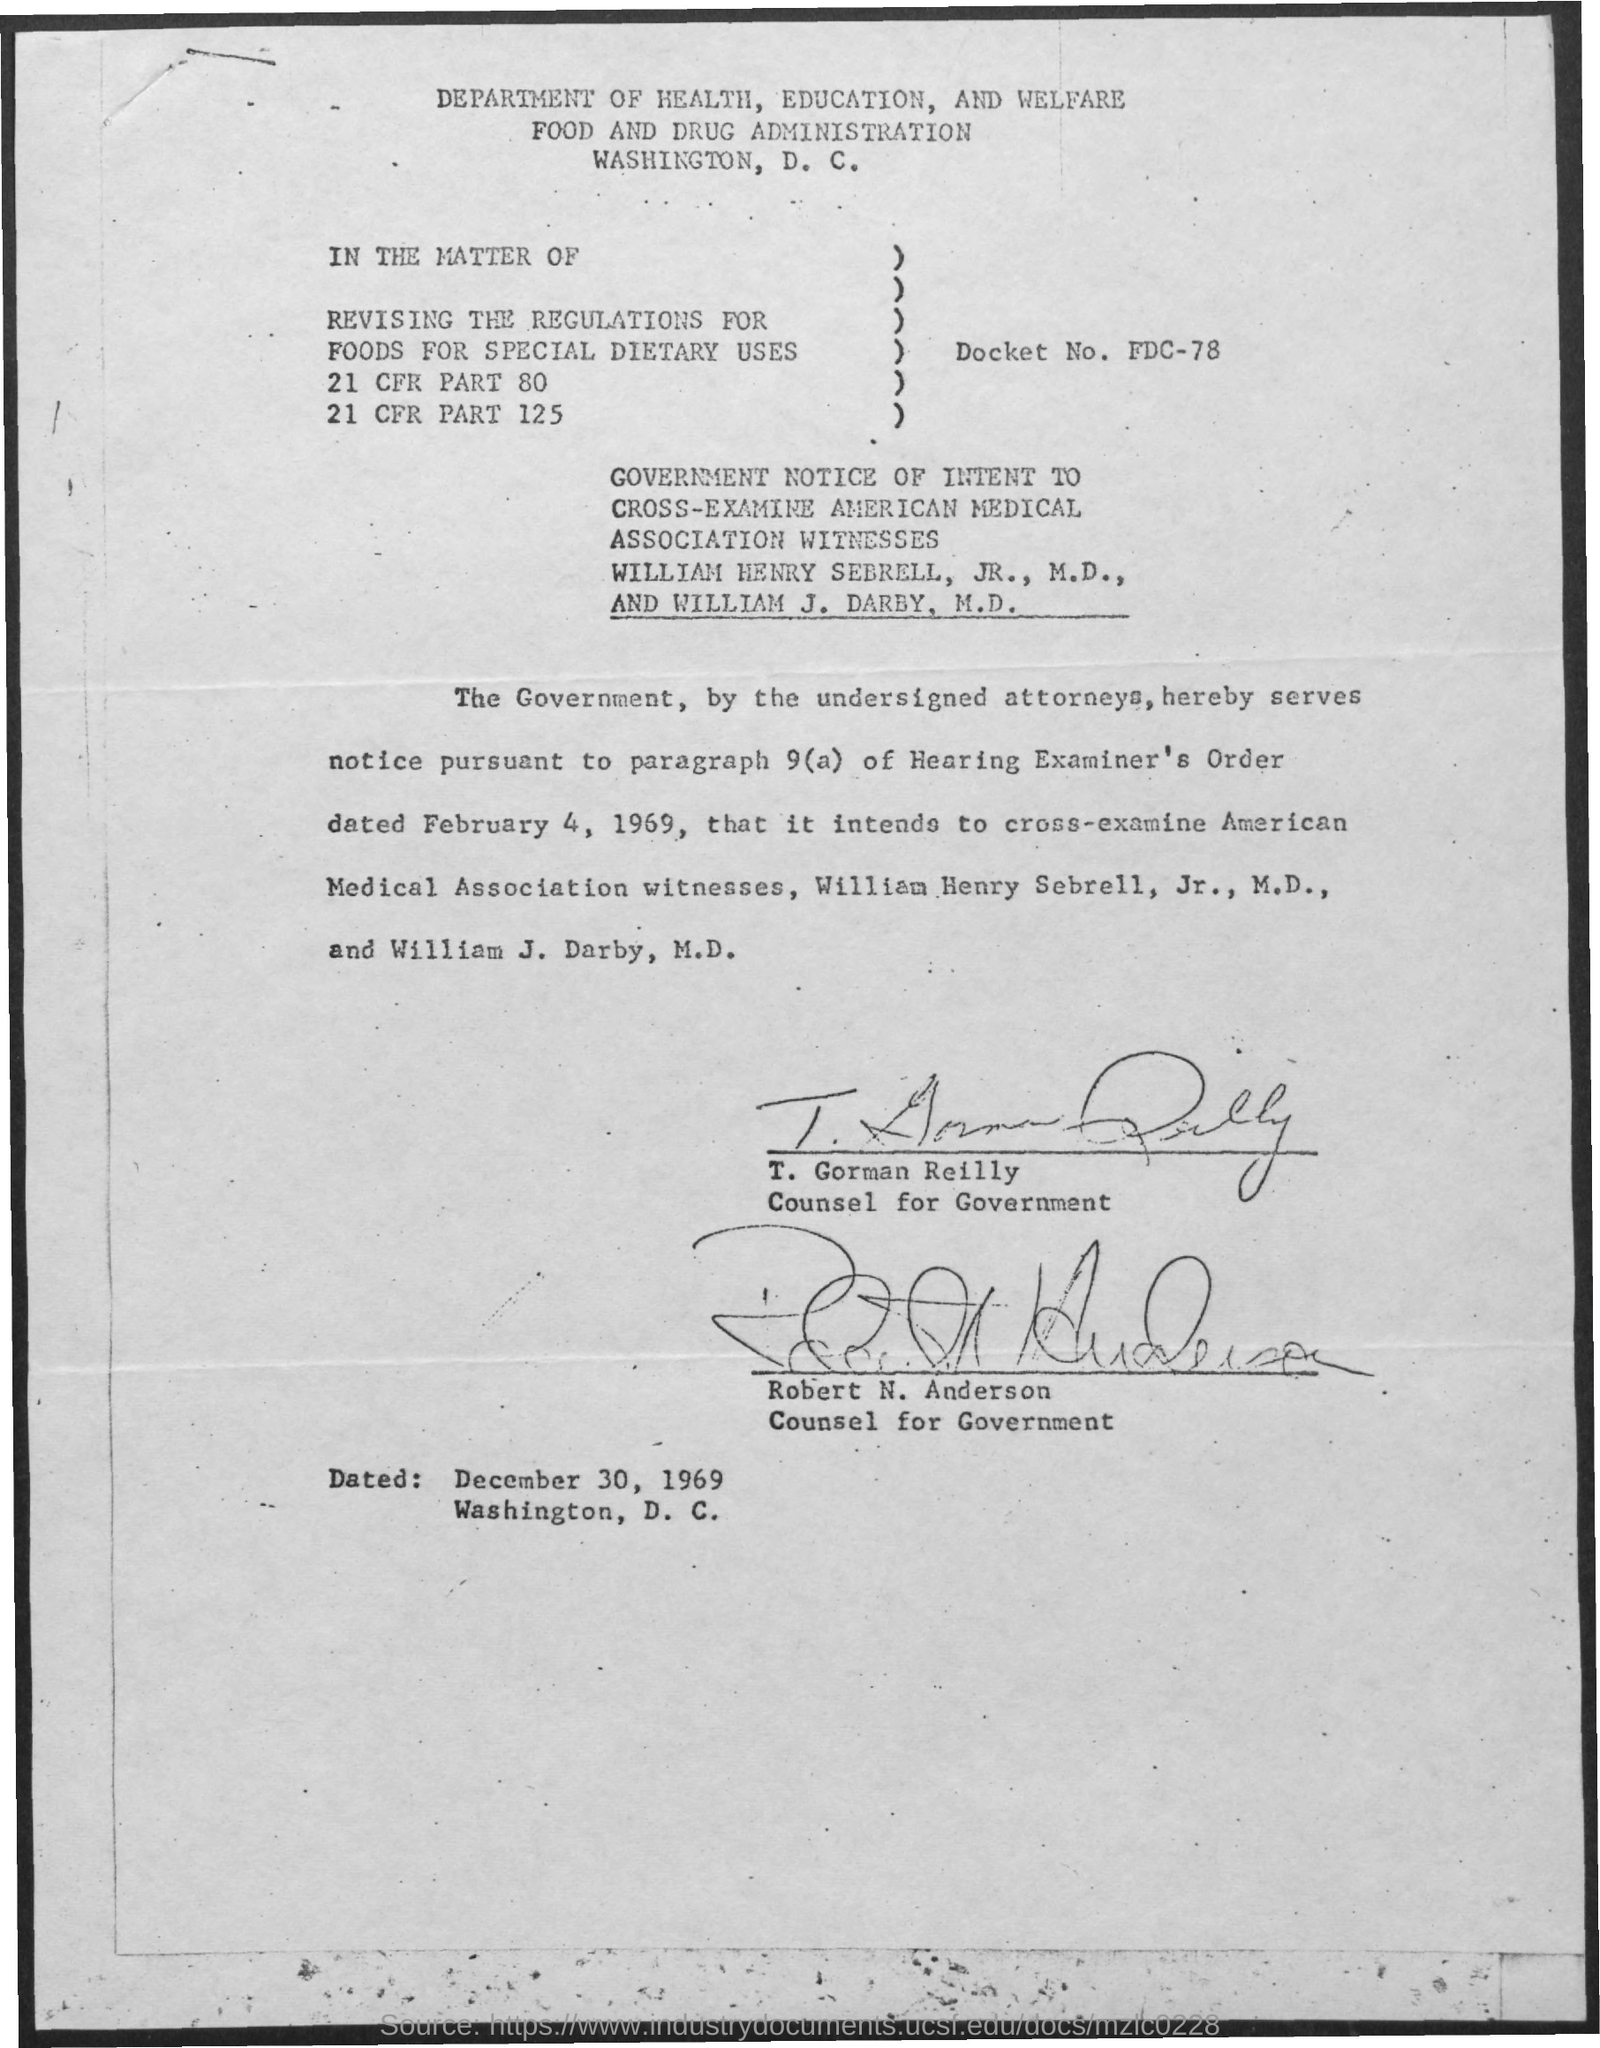What is the second title in the document?
Keep it short and to the point. Food and drug administration. What is the docket number?
Offer a terse response. FDC-78. Who is T. Gorman Reilly?
Provide a short and direct response. Counsel for Government. Who is Robert N. Anderson?
Offer a terse response. Counsel for government. 